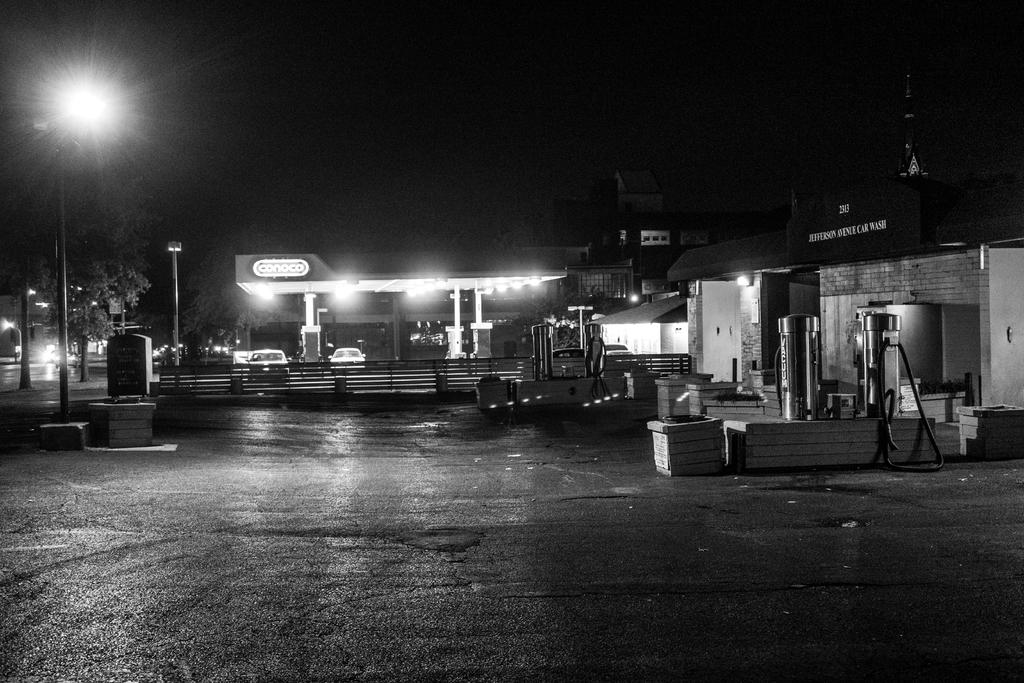What type of establishment is shown in the image? There is a petrol bunk in the image. What can be found inside the petrol bunk? There are vehicles inside the petrol bunk. What can be seen illuminated in the image? There are lights visible in the image. What type of natural vegetation is present in the image? There are trees in the image. What type of barrier is present in the image? There is a fence in the image. What can be seen in the background of the image? There are trees and buildings in the background of the image. Can you tell me how many times the snake sneezes in the image? There is no snake present in the image, so it is not possible to determine how many times it might sneeze. 